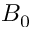<formula> <loc_0><loc_0><loc_500><loc_500>B _ { 0 }</formula> 